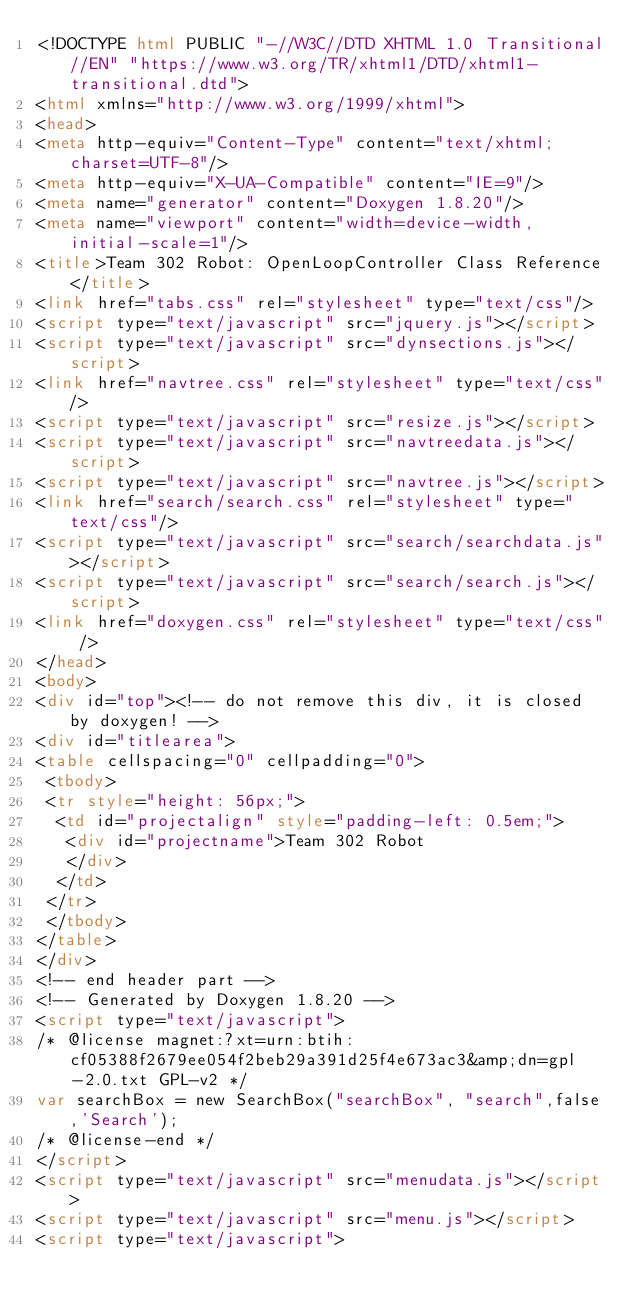Convert code to text. <code><loc_0><loc_0><loc_500><loc_500><_HTML_><!DOCTYPE html PUBLIC "-//W3C//DTD XHTML 1.0 Transitional//EN" "https://www.w3.org/TR/xhtml1/DTD/xhtml1-transitional.dtd">
<html xmlns="http://www.w3.org/1999/xhtml">
<head>
<meta http-equiv="Content-Type" content="text/xhtml;charset=UTF-8"/>
<meta http-equiv="X-UA-Compatible" content="IE=9"/>
<meta name="generator" content="Doxygen 1.8.20"/>
<meta name="viewport" content="width=device-width, initial-scale=1"/>
<title>Team 302 Robot: OpenLoopController Class Reference</title>
<link href="tabs.css" rel="stylesheet" type="text/css"/>
<script type="text/javascript" src="jquery.js"></script>
<script type="text/javascript" src="dynsections.js"></script>
<link href="navtree.css" rel="stylesheet" type="text/css"/>
<script type="text/javascript" src="resize.js"></script>
<script type="text/javascript" src="navtreedata.js"></script>
<script type="text/javascript" src="navtree.js"></script>
<link href="search/search.css" rel="stylesheet" type="text/css"/>
<script type="text/javascript" src="search/searchdata.js"></script>
<script type="text/javascript" src="search/search.js"></script>
<link href="doxygen.css" rel="stylesheet" type="text/css" />
</head>
<body>
<div id="top"><!-- do not remove this div, it is closed by doxygen! -->
<div id="titlearea">
<table cellspacing="0" cellpadding="0">
 <tbody>
 <tr style="height: 56px;">
  <td id="projectalign" style="padding-left: 0.5em;">
   <div id="projectname">Team 302 Robot
   </div>
  </td>
 </tr>
 </tbody>
</table>
</div>
<!-- end header part -->
<!-- Generated by Doxygen 1.8.20 -->
<script type="text/javascript">
/* @license magnet:?xt=urn:btih:cf05388f2679ee054f2beb29a391d25f4e673ac3&amp;dn=gpl-2.0.txt GPL-v2 */
var searchBox = new SearchBox("searchBox", "search",false,'Search');
/* @license-end */
</script>
<script type="text/javascript" src="menudata.js"></script>
<script type="text/javascript" src="menu.js"></script>
<script type="text/javascript"></code> 